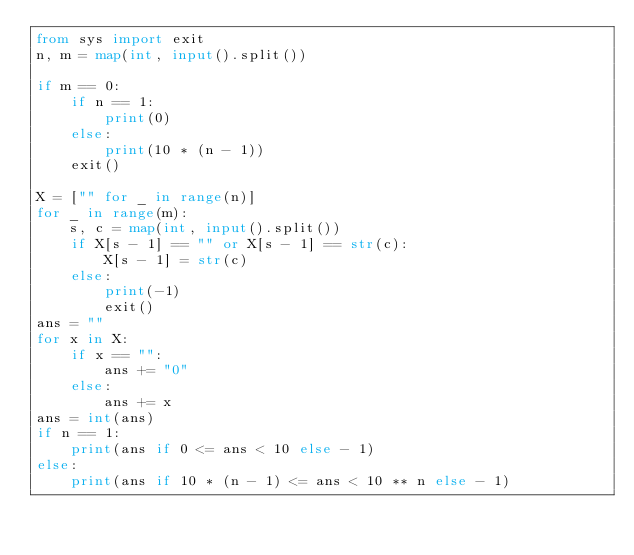<code> <loc_0><loc_0><loc_500><loc_500><_Python_>from sys import exit
n, m = map(int, input().split())

if m == 0:
    if n == 1:
        print(0)
    else:
        print(10 * (n - 1))
    exit()

X = ["" for _ in range(n)]
for _ in range(m):
    s, c = map(int, input().split())
    if X[s - 1] == "" or X[s - 1] == str(c):
        X[s - 1] = str(c)
    else:
        print(-1)
        exit()
ans = ""
for x in X:
    if x == "":
        ans += "0"
    else:
        ans += x
ans = int(ans)
if n == 1:
    print(ans if 0 <= ans < 10 else - 1)
else:
    print(ans if 10 * (n - 1) <= ans < 10 ** n else - 1)
</code> 